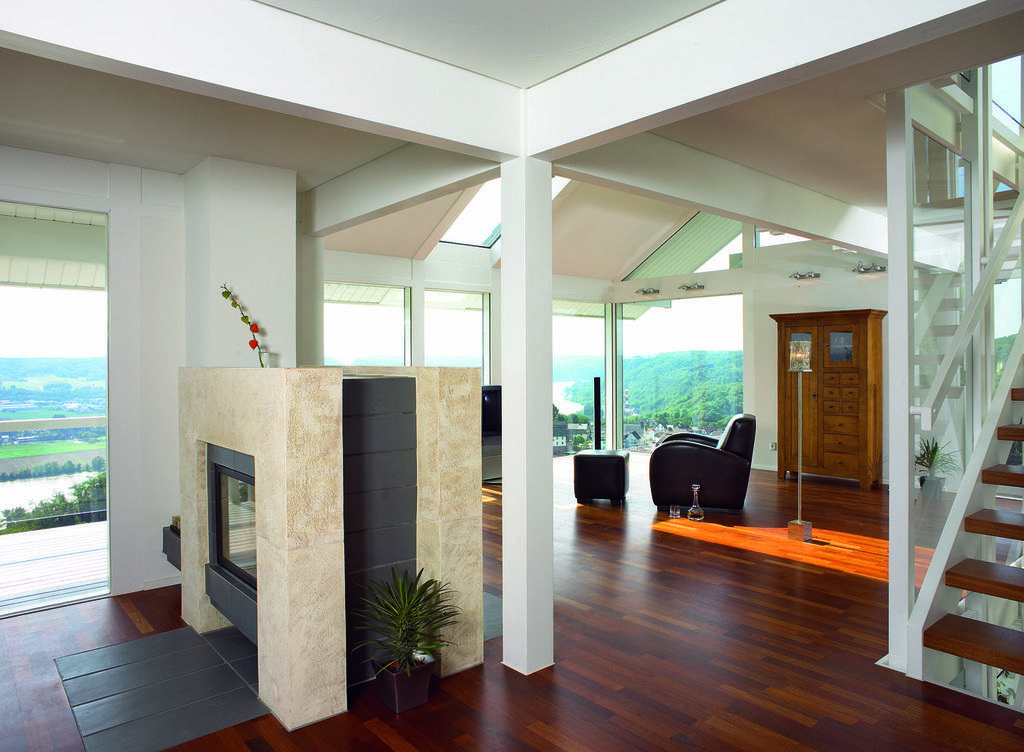In one or two sentences, can you explain what this image depicts? In this picture we can see inside of the building, we can see chair, table, potted plants on the table and we can see stare cases. 